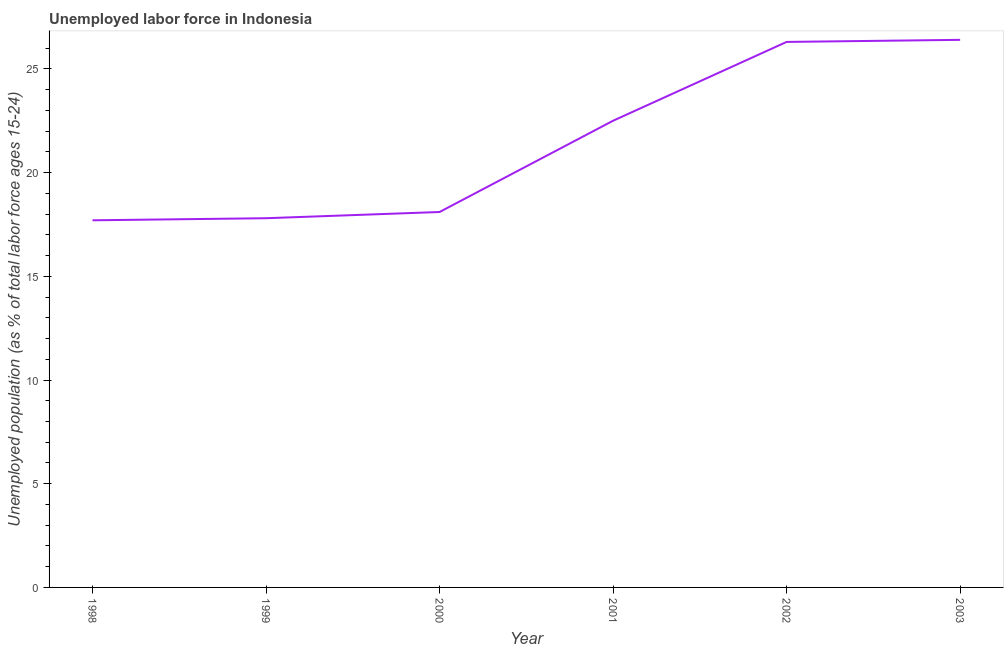What is the total unemployed youth population in 2000?
Your response must be concise. 18.1. Across all years, what is the maximum total unemployed youth population?
Offer a very short reply. 26.4. Across all years, what is the minimum total unemployed youth population?
Offer a very short reply. 17.7. In which year was the total unemployed youth population maximum?
Ensure brevity in your answer.  2003. In which year was the total unemployed youth population minimum?
Provide a short and direct response. 1998. What is the sum of the total unemployed youth population?
Your answer should be compact. 128.8. What is the difference between the total unemployed youth population in 2002 and 2003?
Give a very brief answer. -0.1. What is the average total unemployed youth population per year?
Make the answer very short. 21.47. What is the median total unemployed youth population?
Offer a terse response. 20.3. Do a majority of the years between 2003 and 2002 (inclusive) have total unemployed youth population greater than 15 %?
Offer a very short reply. No. What is the ratio of the total unemployed youth population in 1998 to that in 2002?
Your answer should be compact. 0.67. Is the total unemployed youth population in 1999 less than that in 2001?
Ensure brevity in your answer.  Yes. What is the difference between the highest and the second highest total unemployed youth population?
Offer a terse response. 0.1. What is the difference between the highest and the lowest total unemployed youth population?
Offer a terse response. 8.7. What is the difference between two consecutive major ticks on the Y-axis?
Keep it short and to the point. 5. What is the title of the graph?
Keep it short and to the point. Unemployed labor force in Indonesia. What is the label or title of the Y-axis?
Offer a terse response. Unemployed population (as % of total labor force ages 15-24). What is the Unemployed population (as % of total labor force ages 15-24) in 1998?
Your answer should be compact. 17.7. What is the Unemployed population (as % of total labor force ages 15-24) of 1999?
Keep it short and to the point. 17.8. What is the Unemployed population (as % of total labor force ages 15-24) of 2000?
Offer a terse response. 18.1. What is the Unemployed population (as % of total labor force ages 15-24) of 2001?
Ensure brevity in your answer.  22.5. What is the Unemployed population (as % of total labor force ages 15-24) in 2002?
Give a very brief answer. 26.3. What is the Unemployed population (as % of total labor force ages 15-24) of 2003?
Give a very brief answer. 26.4. What is the difference between the Unemployed population (as % of total labor force ages 15-24) in 1998 and 2000?
Your answer should be compact. -0.4. What is the difference between the Unemployed population (as % of total labor force ages 15-24) in 1998 and 2002?
Give a very brief answer. -8.6. What is the difference between the Unemployed population (as % of total labor force ages 15-24) in 2000 and 2002?
Offer a very short reply. -8.2. What is the difference between the Unemployed population (as % of total labor force ages 15-24) in 2000 and 2003?
Provide a succinct answer. -8.3. What is the difference between the Unemployed population (as % of total labor force ages 15-24) in 2001 and 2002?
Your answer should be compact. -3.8. What is the difference between the Unemployed population (as % of total labor force ages 15-24) in 2001 and 2003?
Offer a terse response. -3.9. What is the difference between the Unemployed population (as % of total labor force ages 15-24) in 2002 and 2003?
Offer a terse response. -0.1. What is the ratio of the Unemployed population (as % of total labor force ages 15-24) in 1998 to that in 2001?
Make the answer very short. 0.79. What is the ratio of the Unemployed population (as % of total labor force ages 15-24) in 1998 to that in 2002?
Make the answer very short. 0.67. What is the ratio of the Unemployed population (as % of total labor force ages 15-24) in 1998 to that in 2003?
Your response must be concise. 0.67. What is the ratio of the Unemployed population (as % of total labor force ages 15-24) in 1999 to that in 2001?
Give a very brief answer. 0.79. What is the ratio of the Unemployed population (as % of total labor force ages 15-24) in 1999 to that in 2002?
Your response must be concise. 0.68. What is the ratio of the Unemployed population (as % of total labor force ages 15-24) in 1999 to that in 2003?
Provide a short and direct response. 0.67. What is the ratio of the Unemployed population (as % of total labor force ages 15-24) in 2000 to that in 2001?
Your response must be concise. 0.8. What is the ratio of the Unemployed population (as % of total labor force ages 15-24) in 2000 to that in 2002?
Keep it short and to the point. 0.69. What is the ratio of the Unemployed population (as % of total labor force ages 15-24) in 2000 to that in 2003?
Your answer should be compact. 0.69. What is the ratio of the Unemployed population (as % of total labor force ages 15-24) in 2001 to that in 2002?
Keep it short and to the point. 0.86. What is the ratio of the Unemployed population (as % of total labor force ages 15-24) in 2001 to that in 2003?
Give a very brief answer. 0.85. What is the ratio of the Unemployed population (as % of total labor force ages 15-24) in 2002 to that in 2003?
Make the answer very short. 1. 